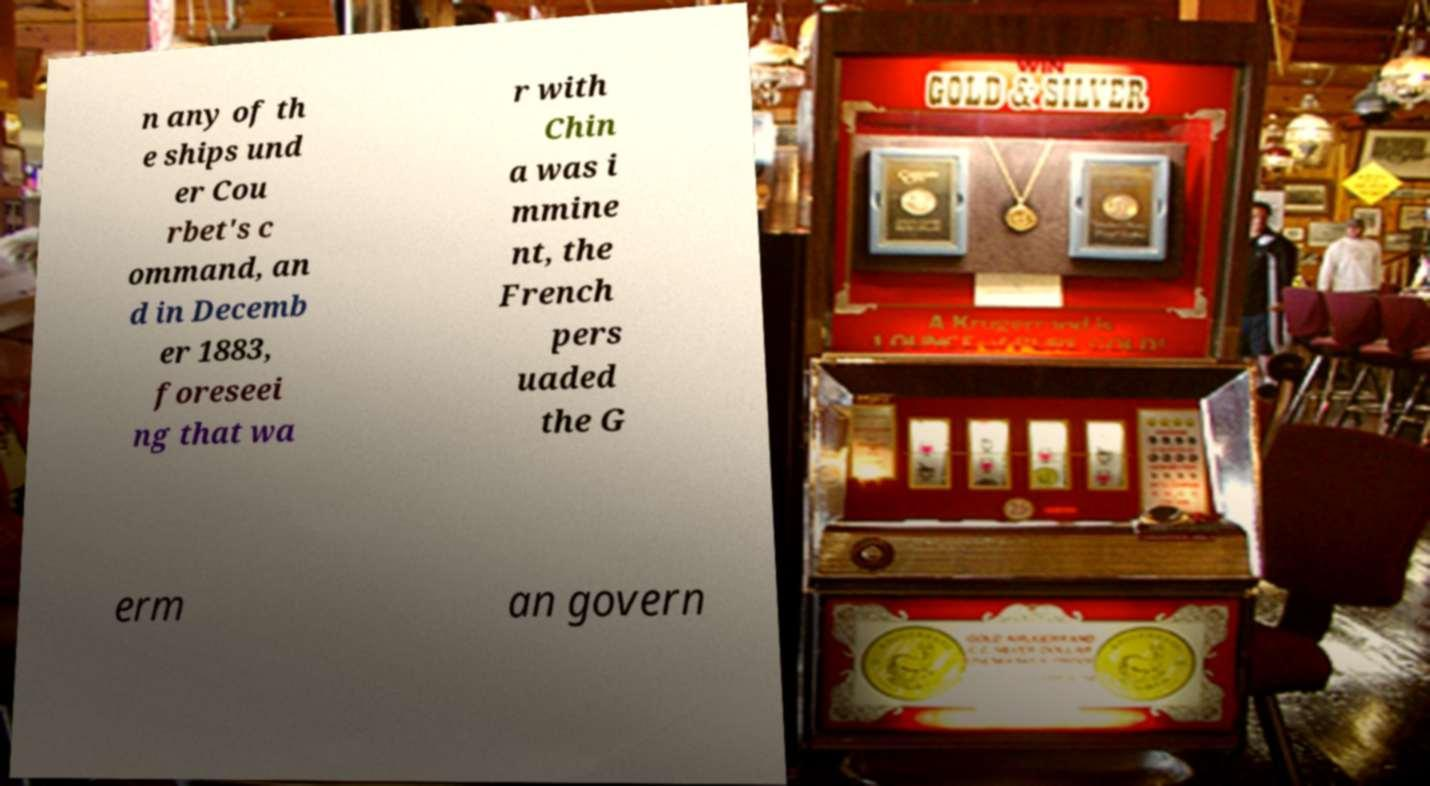Please identify and transcribe the text found in this image. n any of th e ships und er Cou rbet's c ommand, an d in Decemb er 1883, foreseei ng that wa r with Chin a was i mmine nt, the French pers uaded the G erm an govern 